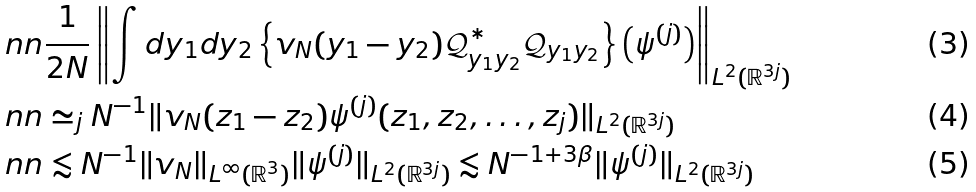Convert formula to latex. <formula><loc_0><loc_0><loc_500><loc_500>& \ n n \frac { 1 } { 2 N } \left \| \int d y _ { 1 } d y _ { 2 } \left \{ v _ { N } ( y _ { 1 } - y _ { 2 } ) \mathcal { Q } ^ { \ast } _ { y _ { 1 } y _ { 2 } } \mathcal { Q } _ { y _ { 1 } y _ { 2 } } \right \} \left ( \psi ^ { ( j ) } \right ) \right \| _ { L ^ { 2 } ( \mathbb { R } ^ { 3 j } ) } \\ & \ n n \simeq _ { j } N ^ { - 1 } \| v _ { N } ( z _ { 1 } - z _ { 2 } ) \psi ^ { ( j ) } ( z _ { 1 } , z _ { 2 } , \dots , z _ { j } ) \| _ { L ^ { 2 } ( \mathbb { R } ^ { 3 j } ) } \\ & \ n n \lesssim N ^ { - 1 } \| v _ { N } \| _ { L ^ { \infty } ( \mathbb { R } ^ { 3 } ) } \| \psi ^ { ( j ) } \| _ { L ^ { 2 } ( \mathbb { R } ^ { 3 j } ) } \lesssim N ^ { - 1 + 3 \beta } \| \psi ^ { ( j ) } \| _ { L ^ { 2 } ( \mathbb { R } ^ { 3 j } ) }</formula> 